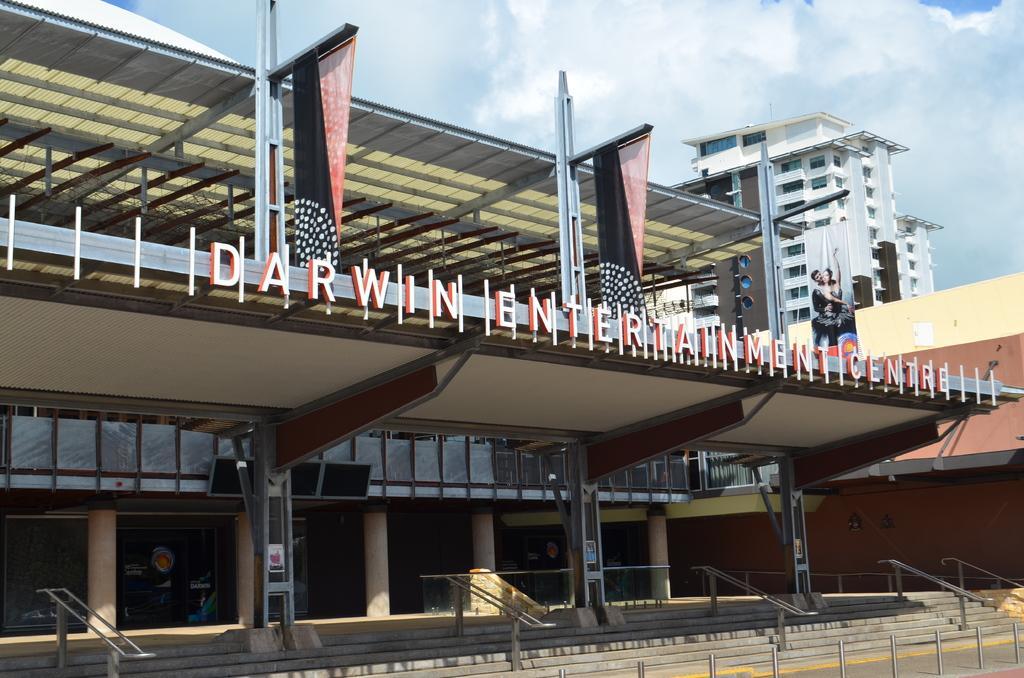Could you give a brief overview of what you see in this image? In this image, we can see buildings. There are steps at the bottom of the image. There is a banner on the right side of the image. There are clouds in the sky. 